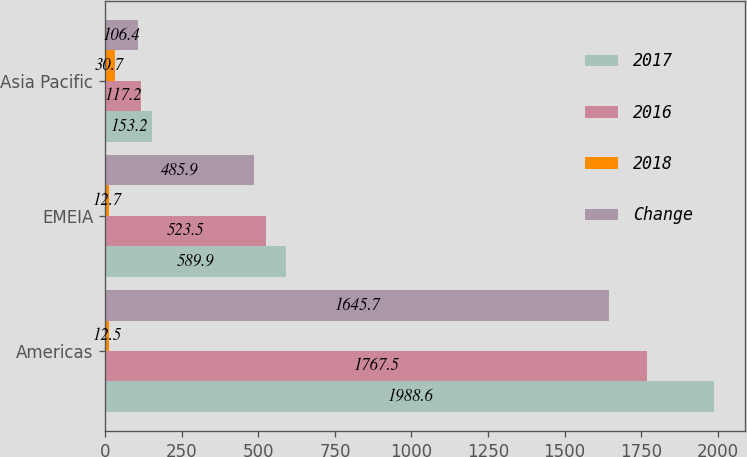Convert chart. <chart><loc_0><loc_0><loc_500><loc_500><stacked_bar_chart><ecel><fcel>Americas<fcel>EMEIA<fcel>Asia Pacific<nl><fcel>2017<fcel>1988.6<fcel>589.9<fcel>153.2<nl><fcel>2016<fcel>1767.5<fcel>523.5<fcel>117.2<nl><fcel>2018<fcel>12.5<fcel>12.7<fcel>30.7<nl><fcel>Change<fcel>1645.7<fcel>485.9<fcel>106.4<nl></chart> 